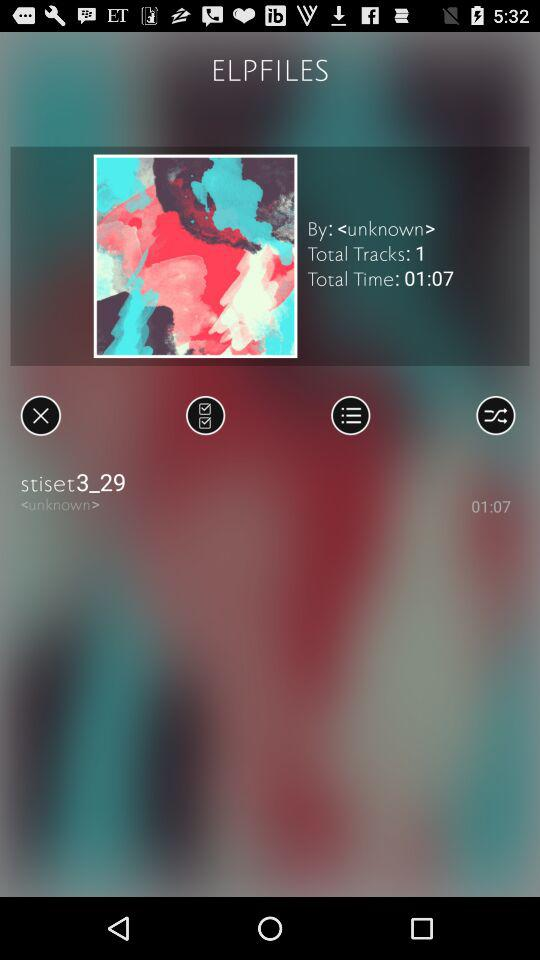What is the track name? The track name is "stiset3_29". 